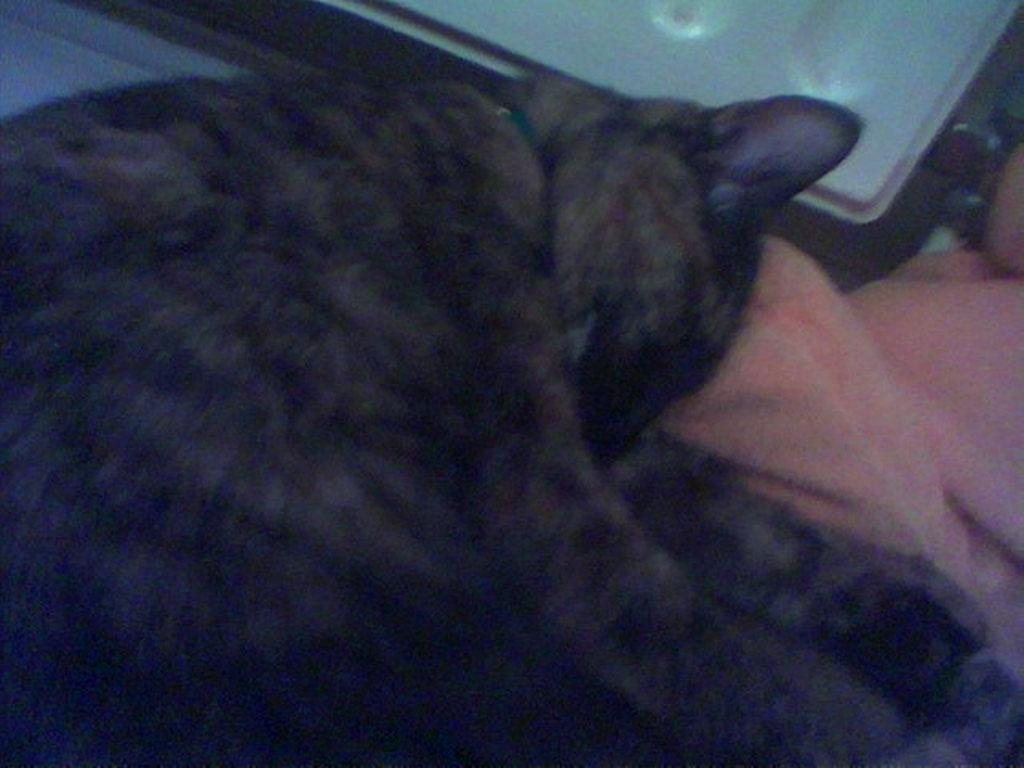What type of animal is in the image? There is a cat in the image. Where is the cat located in the image? The cat is in the front of the image. What is at the bottom of the image? There is a cloth at the bottom of the image. What type of cover is being exchanged between the cat and the cloth in the image? There is no cover being exchanged between the cat and the cloth in the image; the cat is simply located in front of the cloth. What role does the pail play in the image? There is no pail present in the image. 